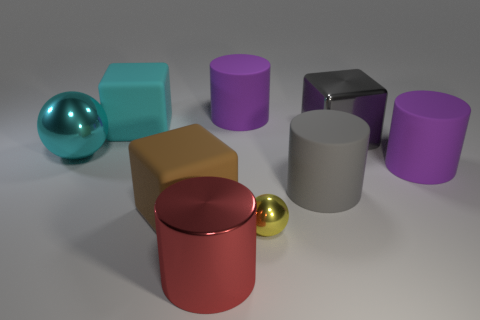Subtract all purple cylinders. How many were subtracted if there are1purple cylinders left? 1 Subtract all blue cubes. How many purple cylinders are left? 2 Add 1 brown things. How many objects exist? 10 Subtract all big red cylinders. How many cylinders are left? 3 Subtract all gray cylinders. How many cylinders are left? 3 Subtract 2 cylinders. How many cylinders are left? 2 Subtract all spheres. How many objects are left? 7 Subtract all cyan cylinders. Subtract all brown spheres. How many cylinders are left? 4 Add 7 metallic cubes. How many metallic cubes are left? 8 Add 9 large cyan metallic spheres. How many large cyan metallic spheres exist? 10 